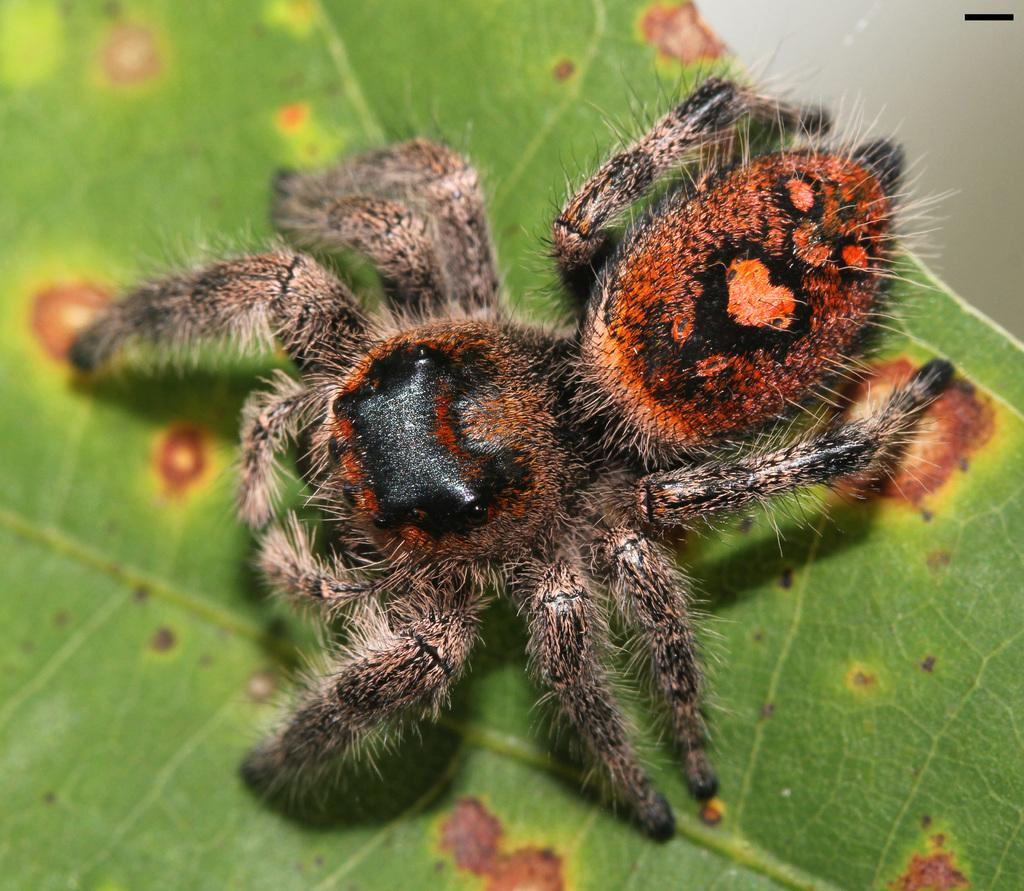What type of creature can be seen in the image? There is an insect in the image. Where is the insect located? The insect is on a leaf. What type of tree is depicted in the image? There is no tree present in the image; it only features an insect on a leaf. What plot of land is the insect exploring in the image? There is no plot of land mentioned in the image; it only shows an insect on a leaf. 